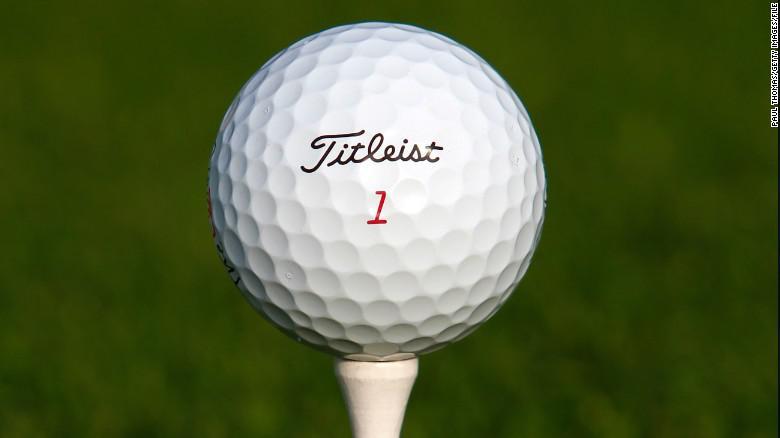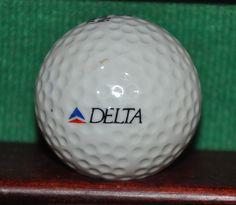The first image is the image on the left, the second image is the image on the right. Assess this claim about the two images: "There are at least seven golf balls.". Correct or not? Answer yes or no. No. 